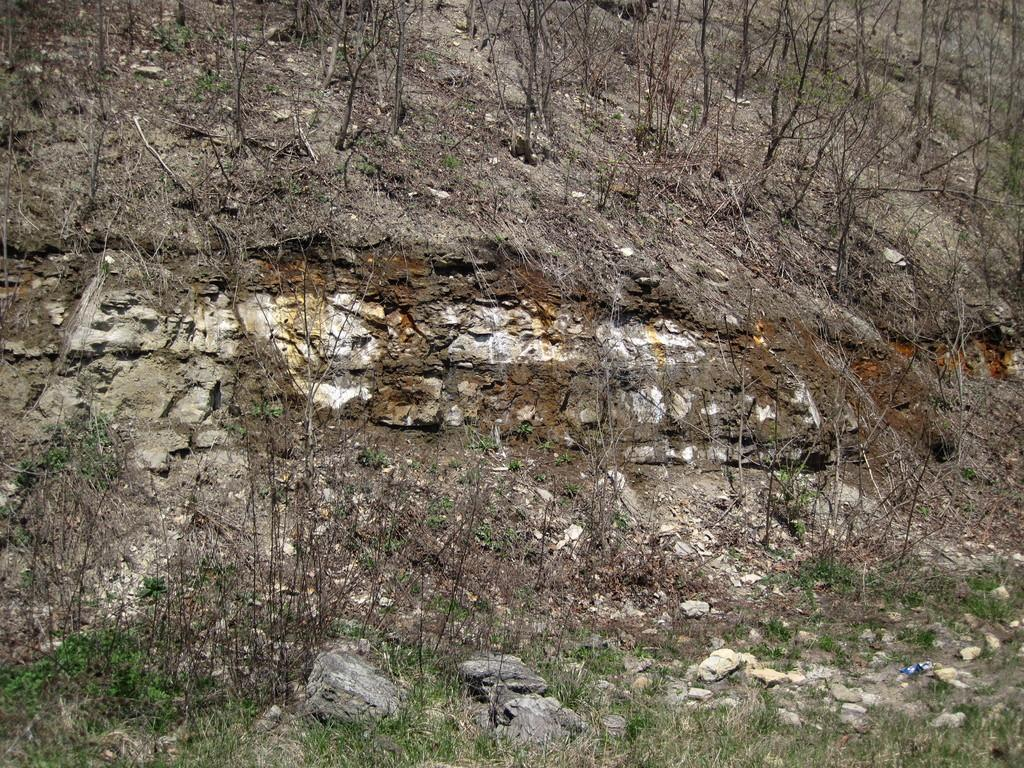What is the primary surface visible in the image? There is a ground in the image. What type of vegetation can be seen on the ground? There is a group of trees on the ground. What other objects are present on the ground? There are stones present on the ground. How much weight can the chickens carry in the image? There are no chickens present in the image, so it is not possible to determine their weight or carrying capacity. 